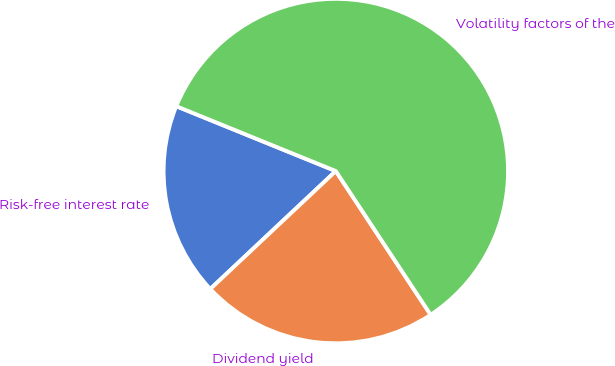Convert chart. <chart><loc_0><loc_0><loc_500><loc_500><pie_chart><fcel>Risk-free interest rate<fcel>Dividend yield<fcel>Volatility factors of the<nl><fcel>18.15%<fcel>22.28%<fcel>59.57%<nl></chart> 